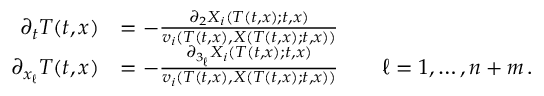Convert formula to latex. <formula><loc_0><loc_0><loc_500><loc_500>\begin{array} { r l } { \partial _ { t } T ( t , x ) } & { = - \frac { \partial _ { 2 } X _ { i } ( T ( t , x ) ; t , x ) } { v _ { i } \left ( T ( t , x ) , X ( T ( t , x ) ; t , x ) \right ) } } \\ { \partial _ { x _ { \ell } } T ( t , x ) } & { = - \frac { \partial _ { 3 _ { \ell } } X _ { i } \left ( T ( t , x ) ; t , x \right ) } { v _ { i } \left ( T ( t , x ) , X \left ( T ( t , x ) ; t , x \right ) \right ) } \quad \ell = 1 , \dots , n + m \, . } \end{array}</formula> 